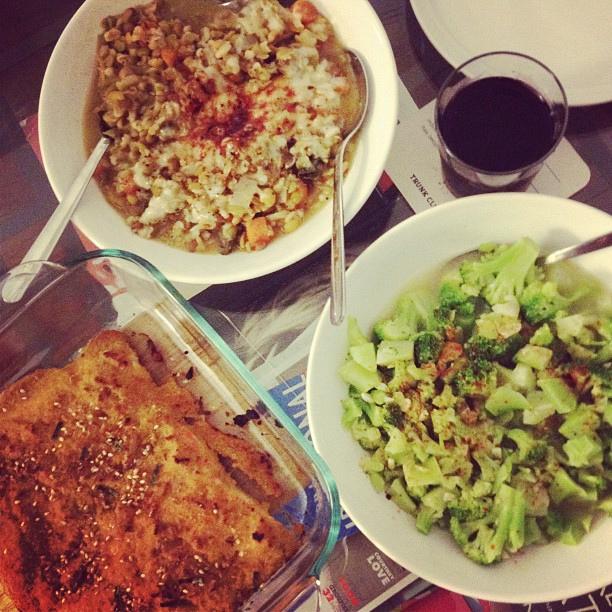What kind of food are these?
Write a very short answer. Side dishes. What is the drink?
Short answer required. Soda. What utensils are in the bowls?
Be succinct. Spoons. 